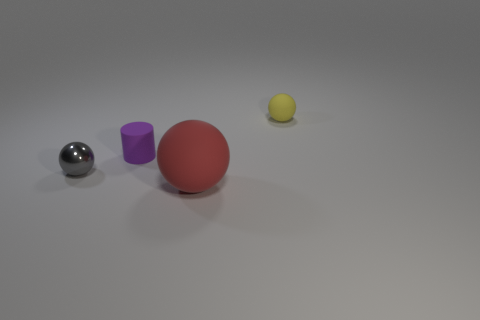Add 2 tiny gray shiny balls. How many objects exist? 6 Subtract all balls. How many objects are left? 1 Subtract all large yellow shiny objects. Subtract all purple matte objects. How many objects are left? 3 Add 4 tiny purple cylinders. How many tiny purple cylinders are left? 5 Add 1 big blue rubber cubes. How many big blue rubber cubes exist? 1 Subtract 0 cyan cylinders. How many objects are left? 4 